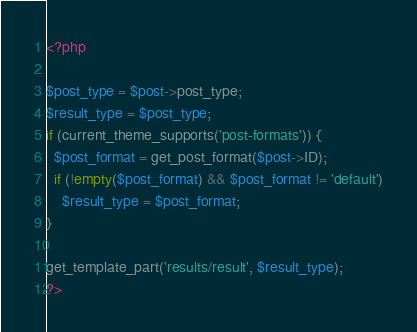<code> <loc_0><loc_0><loc_500><loc_500><_PHP_><?php

$post_type = $post->post_type;
$result_type = $post_type;
if (current_theme_supports('post-formats')) {
  $post_format = get_post_format($post->ID);
  if (!empty($post_format) && $post_format != 'default')
    $result_type = $post_format;
}

get_template_part('results/result', $result_type);
?></code> 